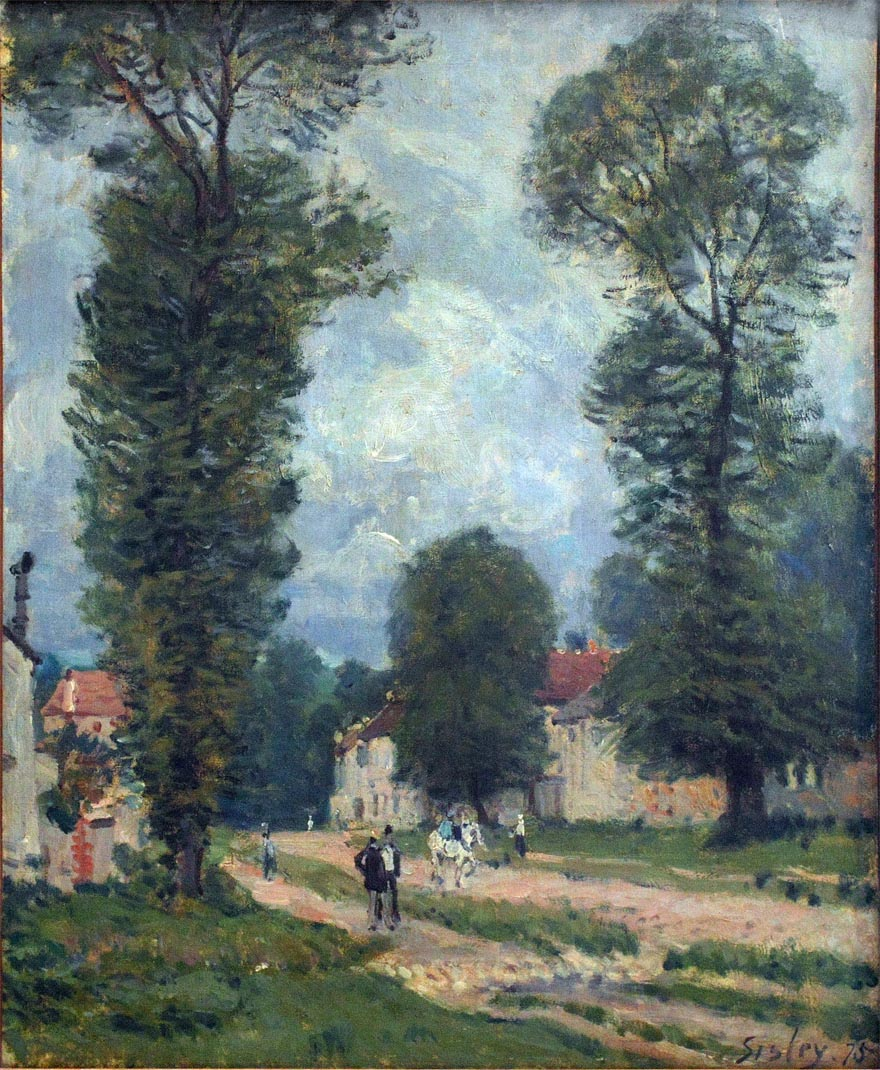What's happening in the scene? The image is a beautiful impressionist painting that captures the serene essence of a rural landscape. It prominently features two tall trees with dark green leaves on the left, painted in the characteristic loose and fluid style of impressionism. A light brown dirt road meanders through the center, inviting the viewer's gaze deeper into the scene. Along this road, several figures including a man on horseback and groups of people walking, bring life and movement into the picture. In the background, the sky is a soft blue sprinkled with delicate, wispy clouds, enhancing the peaceful rural atmosphere. Notably, this work is signed 'Sisley' in the lower right corner, indicating it was crafted by the renowned artist Alfred Sisley. 